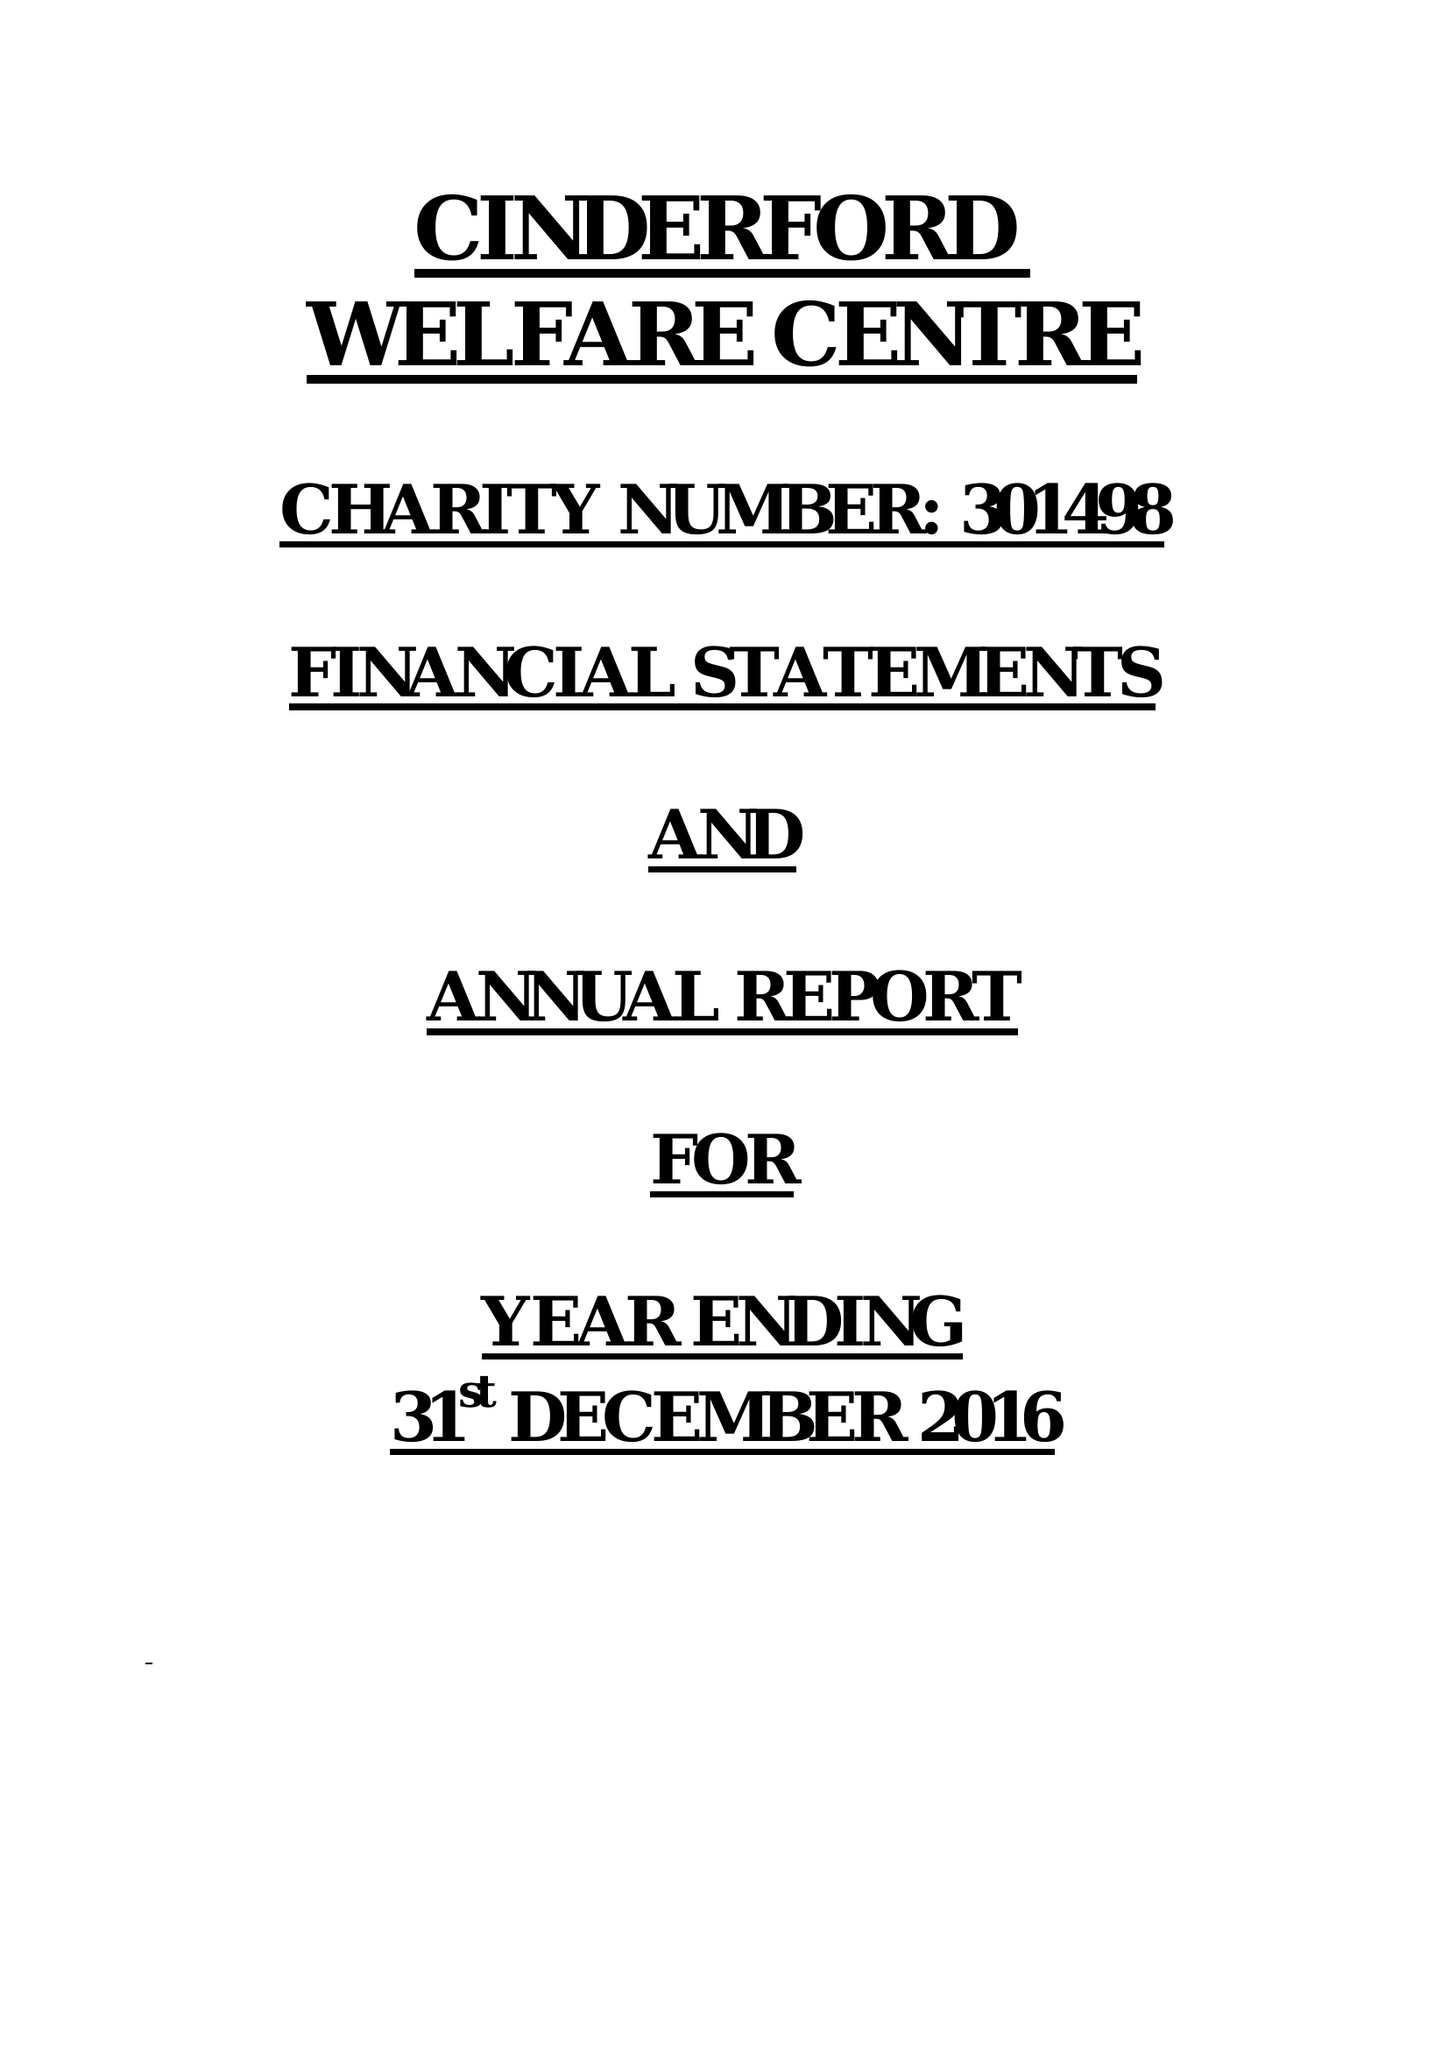What is the value for the address__post_town?
Answer the question using a single word or phrase. CINDERFORD 